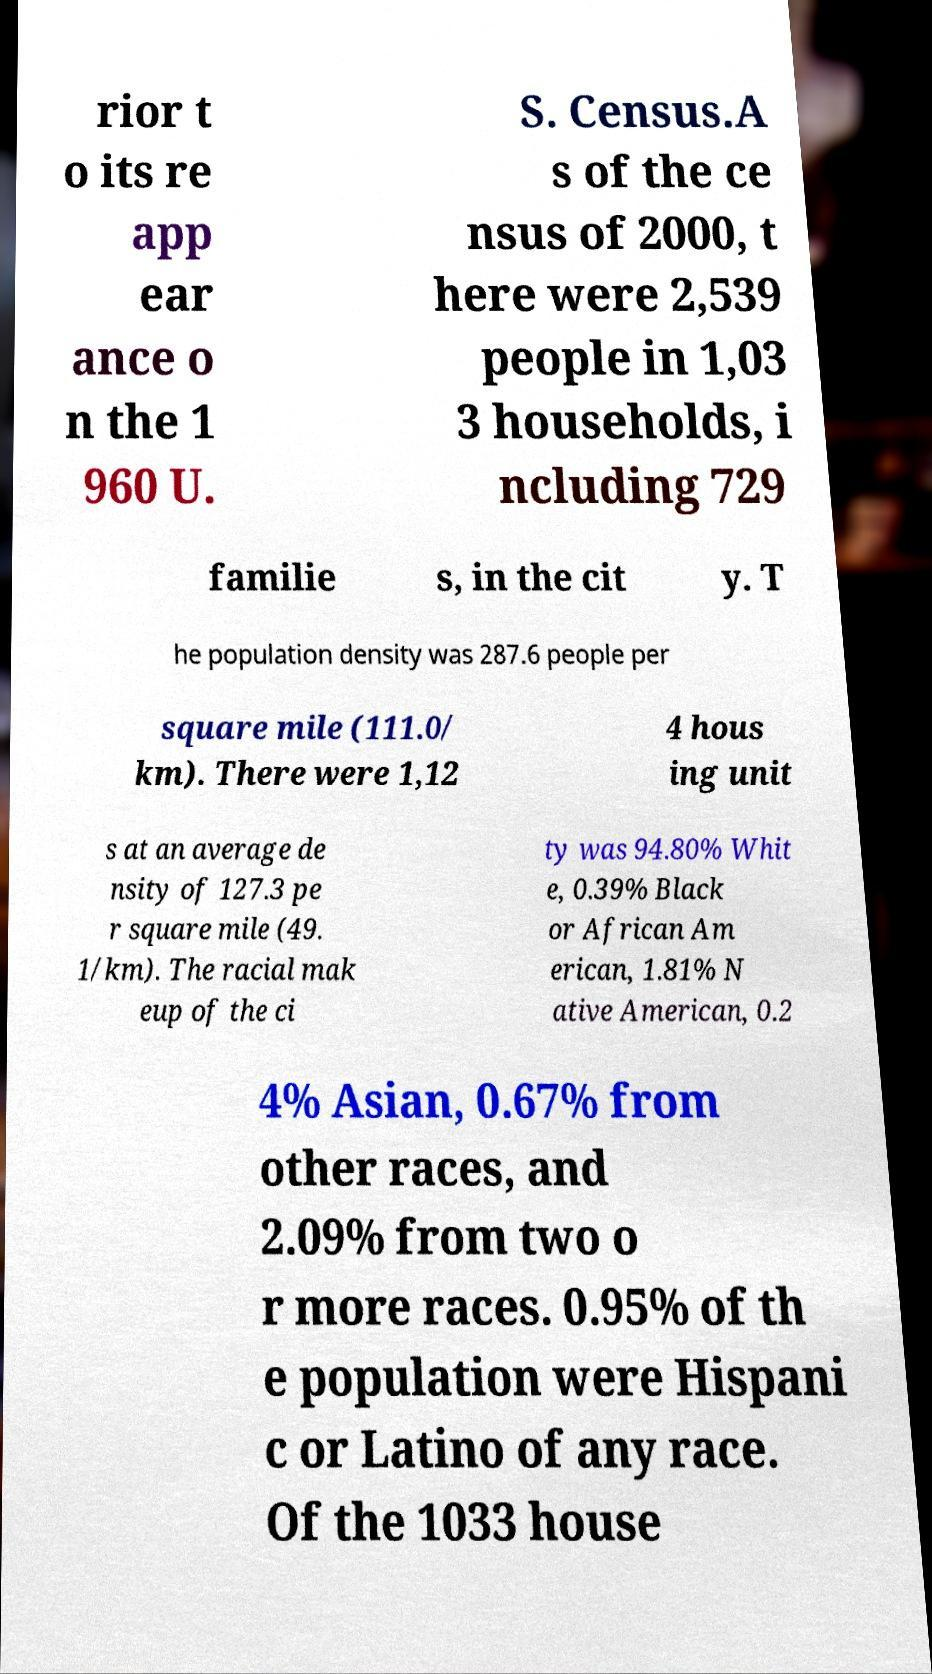There's text embedded in this image that I need extracted. Can you transcribe it verbatim? rior t o its re app ear ance o n the 1 960 U. S. Census.A s of the ce nsus of 2000, t here were 2,539 people in 1,03 3 households, i ncluding 729 familie s, in the cit y. T he population density was 287.6 people per square mile (111.0/ km). There were 1,12 4 hous ing unit s at an average de nsity of 127.3 pe r square mile (49. 1/km). The racial mak eup of the ci ty was 94.80% Whit e, 0.39% Black or African Am erican, 1.81% N ative American, 0.2 4% Asian, 0.67% from other races, and 2.09% from two o r more races. 0.95% of th e population were Hispani c or Latino of any race. Of the 1033 house 